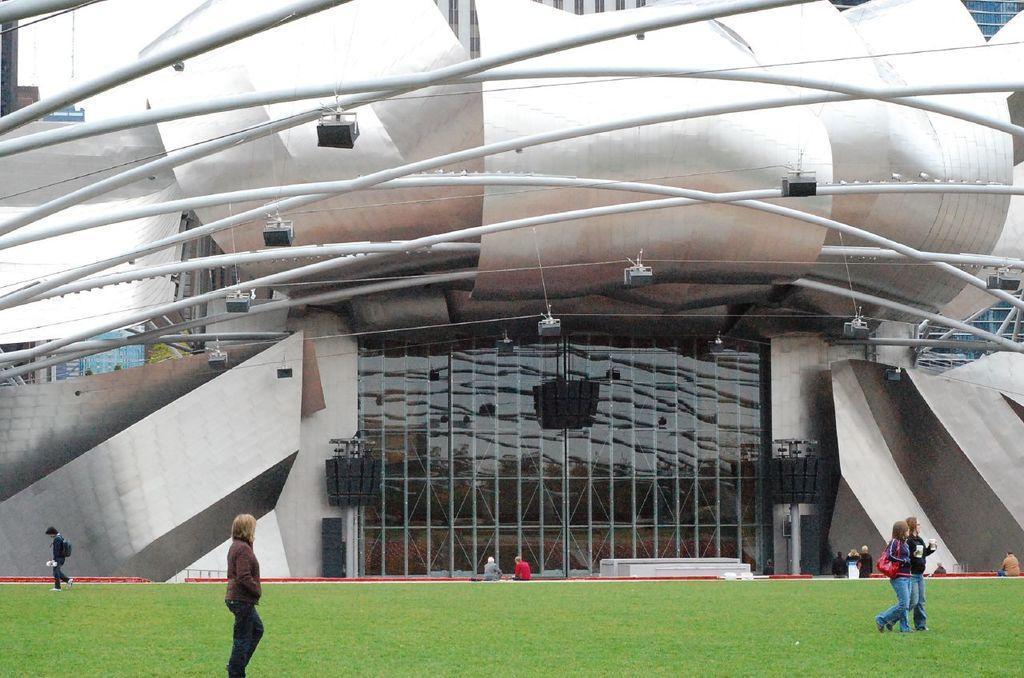In one or two sentences, can you explain what this image depicts? In this image I can see a person standing wearing brown jacket, black pant. Background I can see few other persons some are walking and some are sitting, and building and sky in white color. 